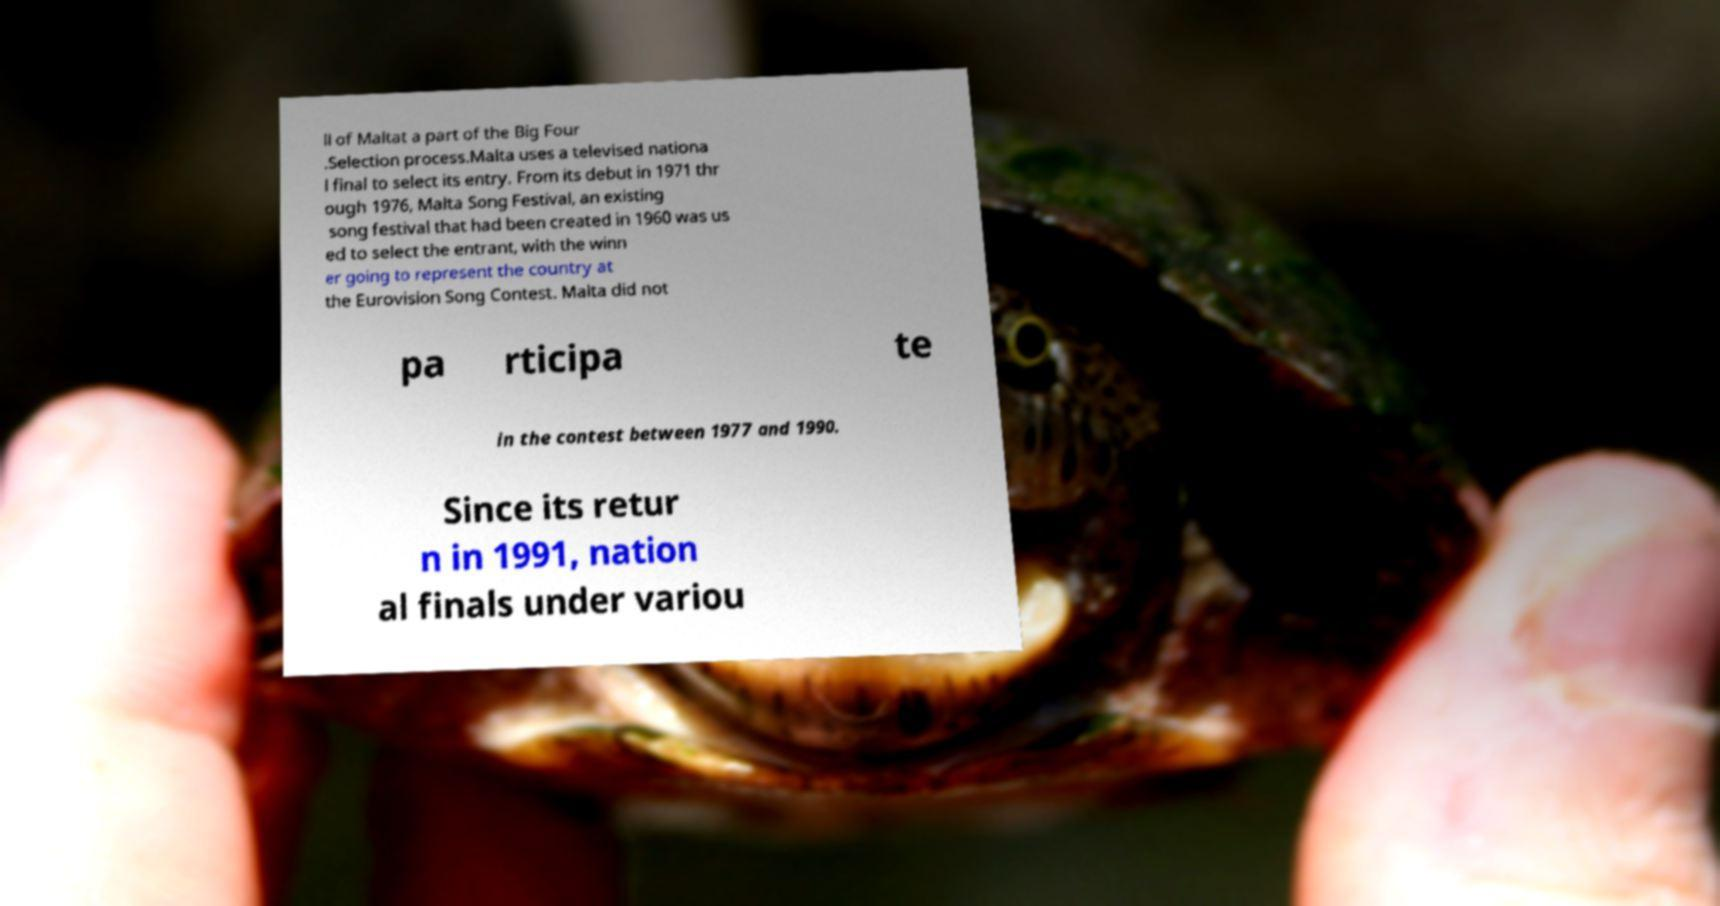There's text embedded in this image that I need extracted. Can you transcribe it verbatim? ll of Maltat a part of the Big Four .Selection process.Malta uses a televised nationa l final to select its entry. From its debut in 1971 thr ough 1976, Malta Song Festival, an existing song festival that had been created in 1960 was us ed to select the entrant, with the winn er going to represent the country at the Eurovision Song Contest. Malta did not pa rticipa te in the contest between 1977 and 1990. Since its retur n in 1991, nation al finals under variou 